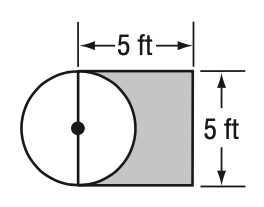Answer the mathemtical geometry problem and directly provide the correct option letter.
Question: One side of a square is a diameter of a circle. The length of one side of the square is 5 feet. To the nearest hundredth, what is the probability that a point chosen at random is in the shaded region?
Choices: A: 0.08 B: 0.22 C: 0.44 D: 0.77 C 